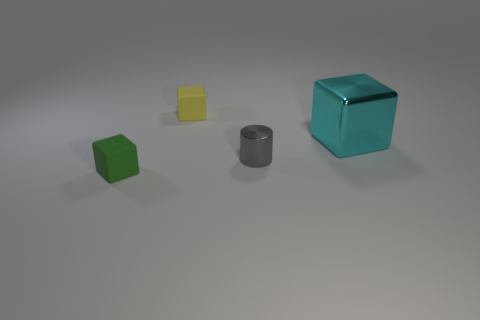Subtract 1 blocks. How many blocks are left? 2 Add 2 large cyan things. How many objects exist? 6 Subtract all gray cubes. Subtract all brown cylinders. How many cubes are left? 3 Subtract all blocks. How many objects are left? 1 Subtract 0 cyan balls. How many objects are left? 4 Subtract all large yellow matte cylinders. Subtract all rubber things. How many objects are left? 2 Add 1 shiny cylinders. How many shiny cylinders are left? 2 Add 3 metal cylinders. How many metal cylinders exist? 4 